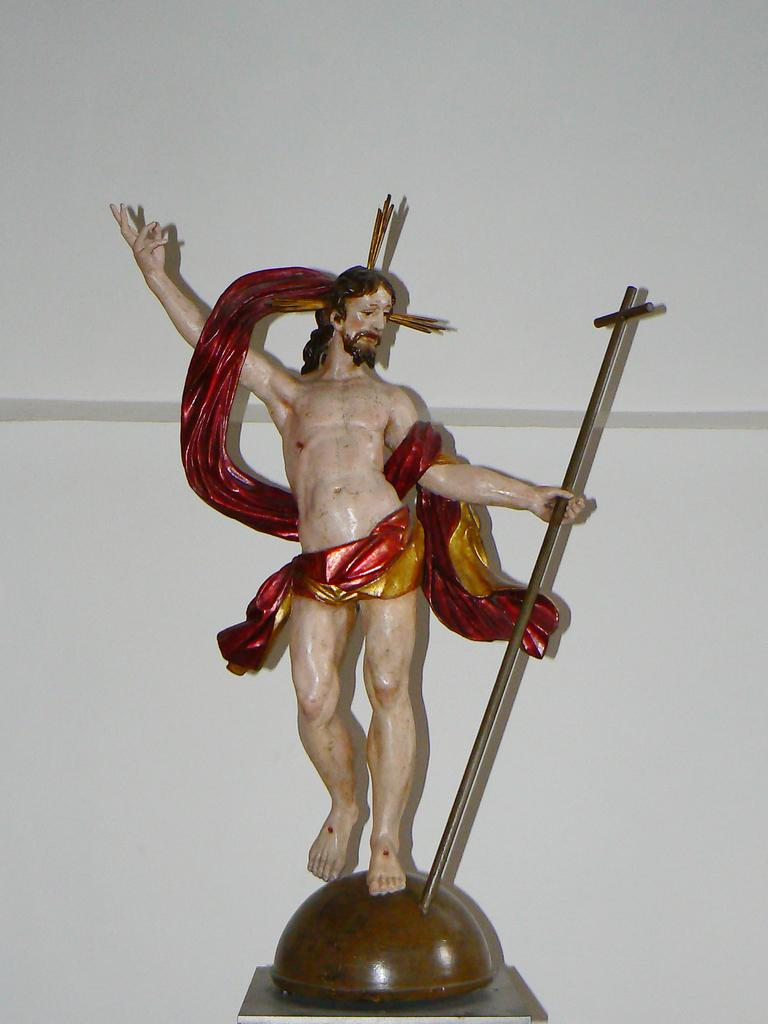What is the main subject in the center of the image? There is a sculpture in the center of the image. What can be seen in the background of the image? There is a wall in the background of the image. What type of sign is visible in the image? There is no sign present in the image; it features a sculpture and a wall in the background. 